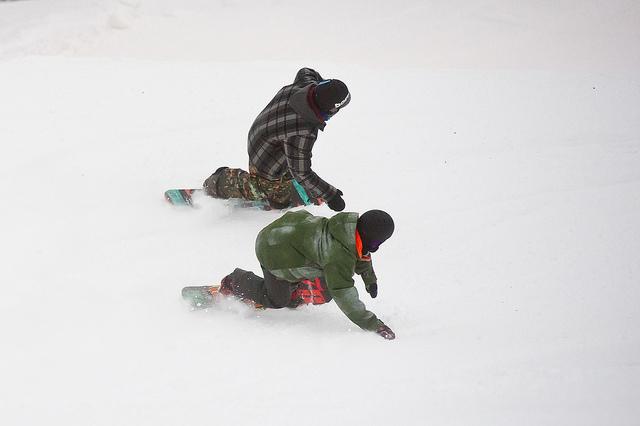What activity are these people doing?
Keep it brief. Snowboarding. Is the snow clean?
Write a very short answer. Yes. Can the two snowboarders remain in control in that position?
Keep it brief. Yes. 